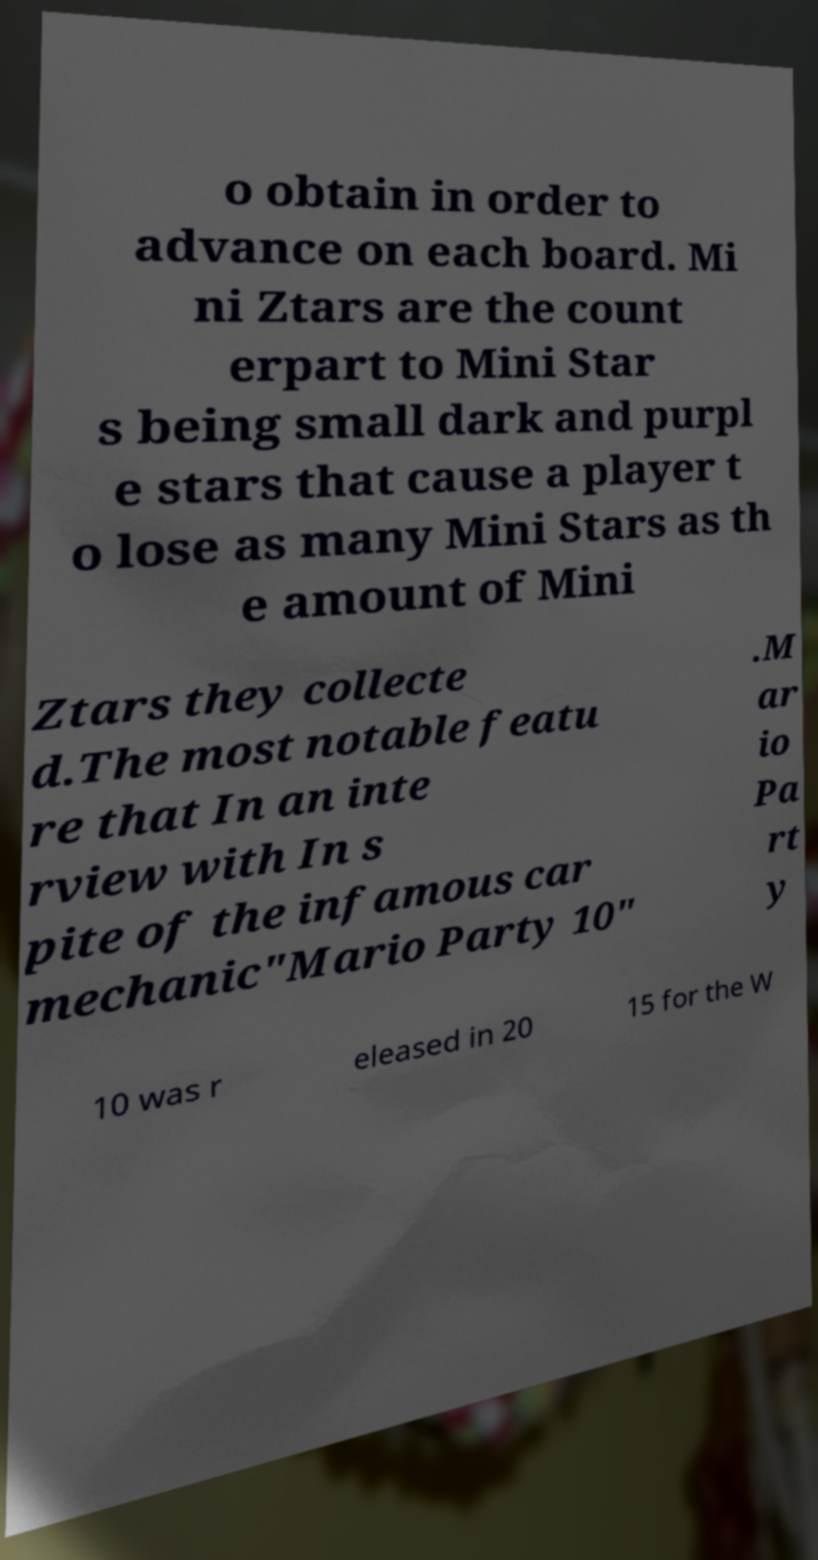Please read and relay the text visible in this image. What does it say? o obtain in order to advance on each board. Mi ni Ztars are the count erpart to Mini Star s being small dark and purpl e stars that cause a player t o lose as many Mini Stars as th e amount of Mini Ztars they collecte d.The most notable featu re that In an inte rview with In s pite of the infamous car mechanic"Mario Party 10" .M ar io Pa rt y 10 was r eleased in 20 15 for the W 